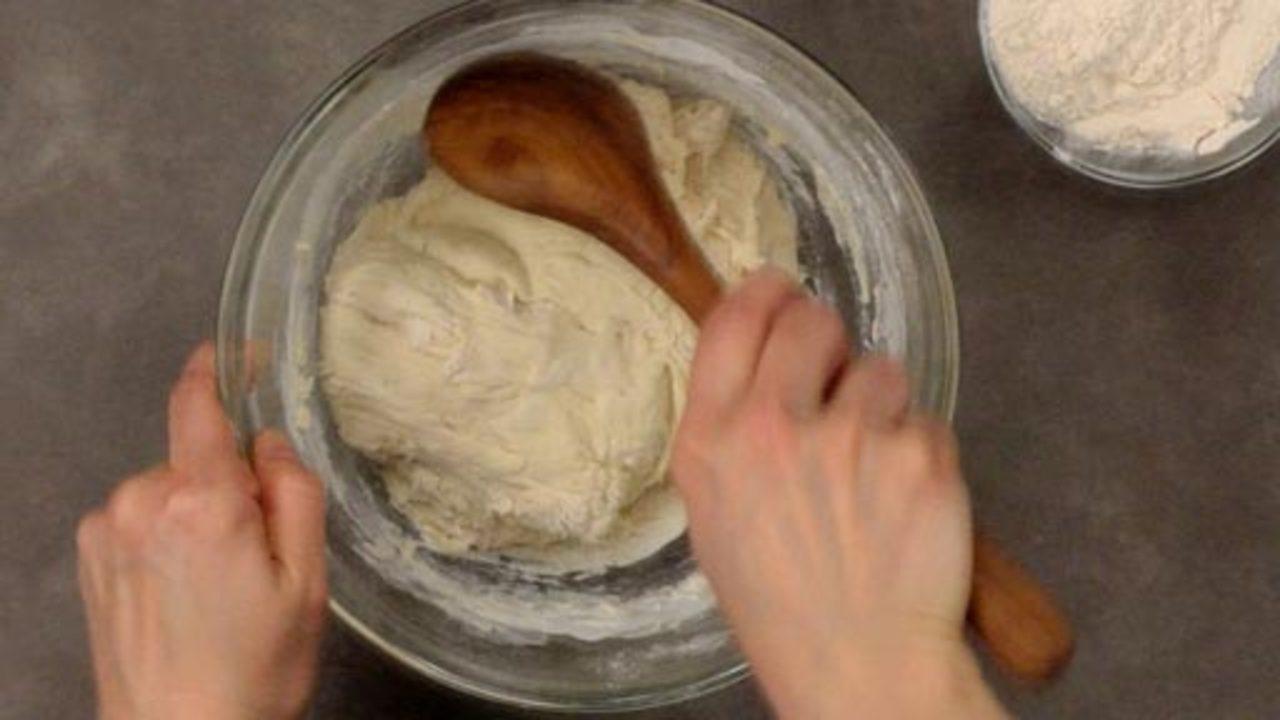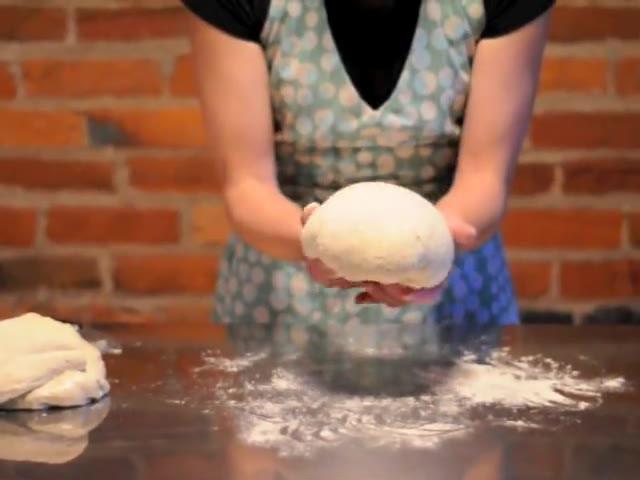The first image is the image on the left, the second image is the image on the right. Given the left and right images, does the statement "There are no wooden utensils present." hold true? Answer yes or no. No. The first image is the image on the left, the second image is the image on the right. Considering the images on both sides, is "The right image shows a pair of hands with fingers touching flattened dough on floured wood," valid? Answer yes or no. No. 